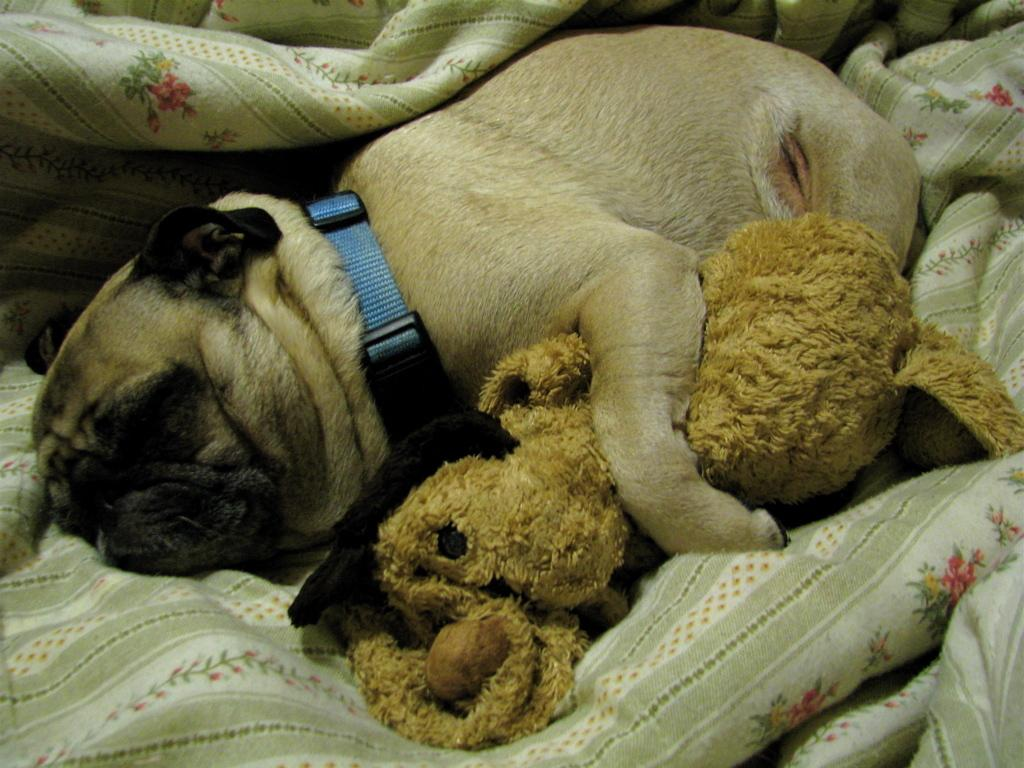What type of animal can be seen in the image? There is a dog in the image. What is the dog doing in the image? The dog is sleeping on a blanket. What else is present in the image besides the dog? There is a toy in the image. What type of skin condition does the dog have in the image? There is no indication of any skin condition in the image; the dog appears to be sleeping peacefully on a blanket. 